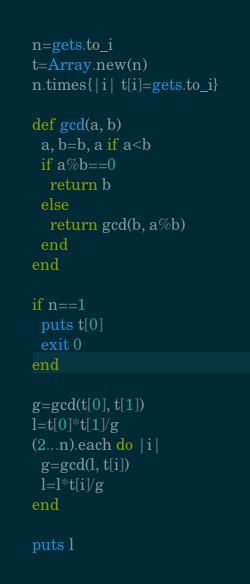<code> <loc_0><loc_0><loc_500><loc_500><_Ruby_>n=gets.to_i
t=Array.new(n)
n.times{|i| t[i]=gets.to_i}

def gcd(a, b)
  a, b=b, a if a<b
  if a%b==0
    return b
  else
    return gcd(b, a%b)
  end
end

if n==1
  puts t[0]
  exit 0
end

g=gcd(t[0], t[1])
l=t[0]*t[1]/g
(2...n).each do |i|
  g=gcd(l, t[i])
  l=l*t[i]/g
end

puts l
</code> 